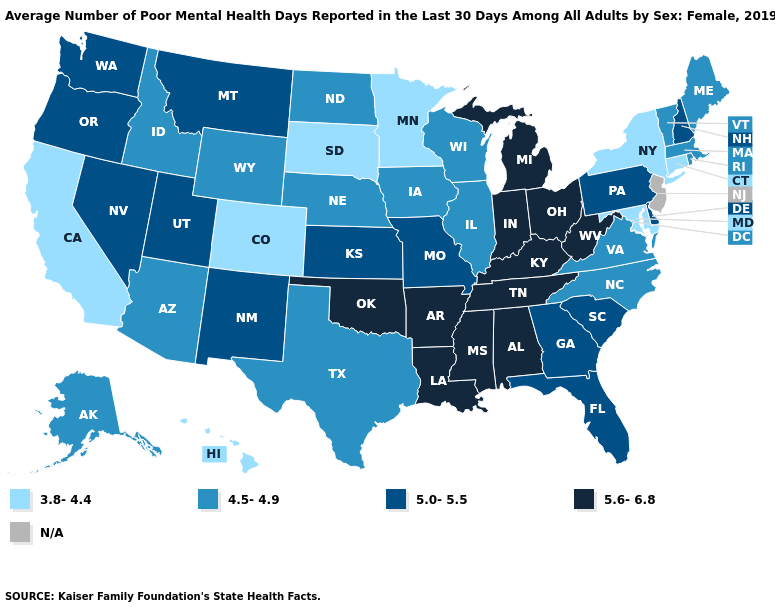Does Wyoming have the highest value in the USA?
Quick response, please. No. What is the lowest value in the Northeast?
Be succinct. 3.8-4.4. Among the states that border Maryland , does West Virginia have the highest value?
Answer briefly. Yes. What is the value of Oklahoma?
Keep it brief. 5.6-6.8. Does the map have missing data?
Write a very short answer. Yes. What is the value of Arkansas?
Keep it brief. 5.6-6.8. Among the states that border New Hampshire , which have the highest value?
Concise answer only. Maine, Massachusetts, Vermont. Does the first symbol in the legend represent the smallest category?
Answer briefly. Yes. What is the highest value in the South ?
Be succinct. 5.6-6.8. What is the value of Idaho?
Keep it brief. 4.5-4.9. Among the states that border Kentucky , does Indiana have the highest value?
Be succinct. Yes. What is the value of Wyoming?
Short answer required. 4.5-4.9. Name the states that have a value in the range 3.8-4.4?
Quick response, please. California, Colorado, Connecticut, Hawaii, Maryland, Minnesota, New York, South Dakota. Among the states that border Vermont , does New York have the highest value?
Concise answer only. No. 